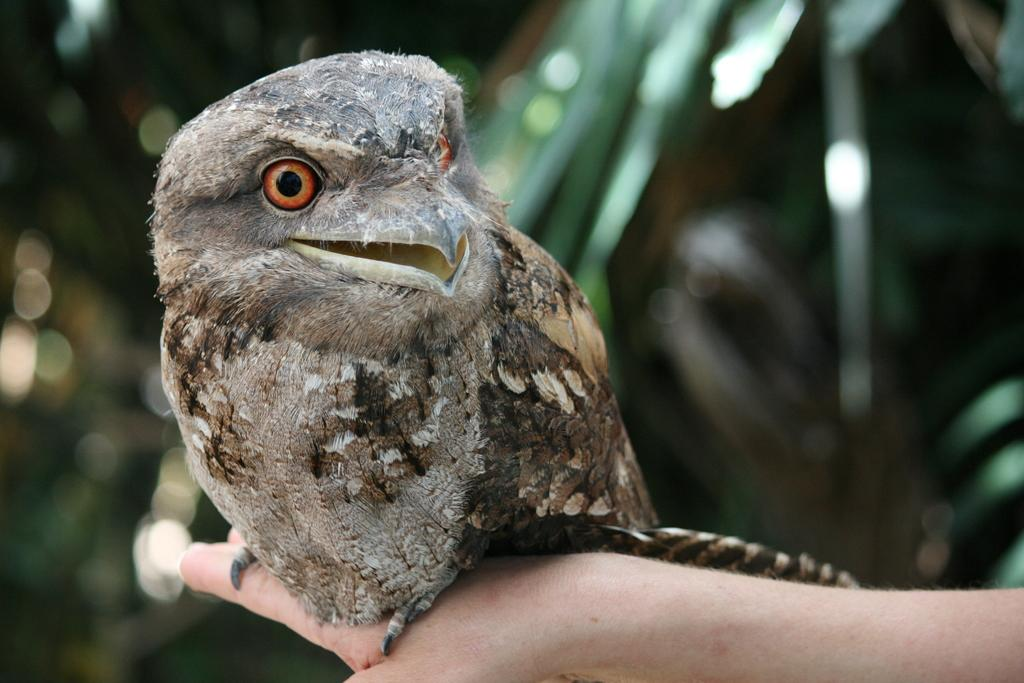What type of animal is in the image? There is a bird in the image. Where is the bird located in the image? The bird is on a person's hand. What type of plants can be seen growing in the bird's nest in the image? There is no bird's nest or plants present in the image. 